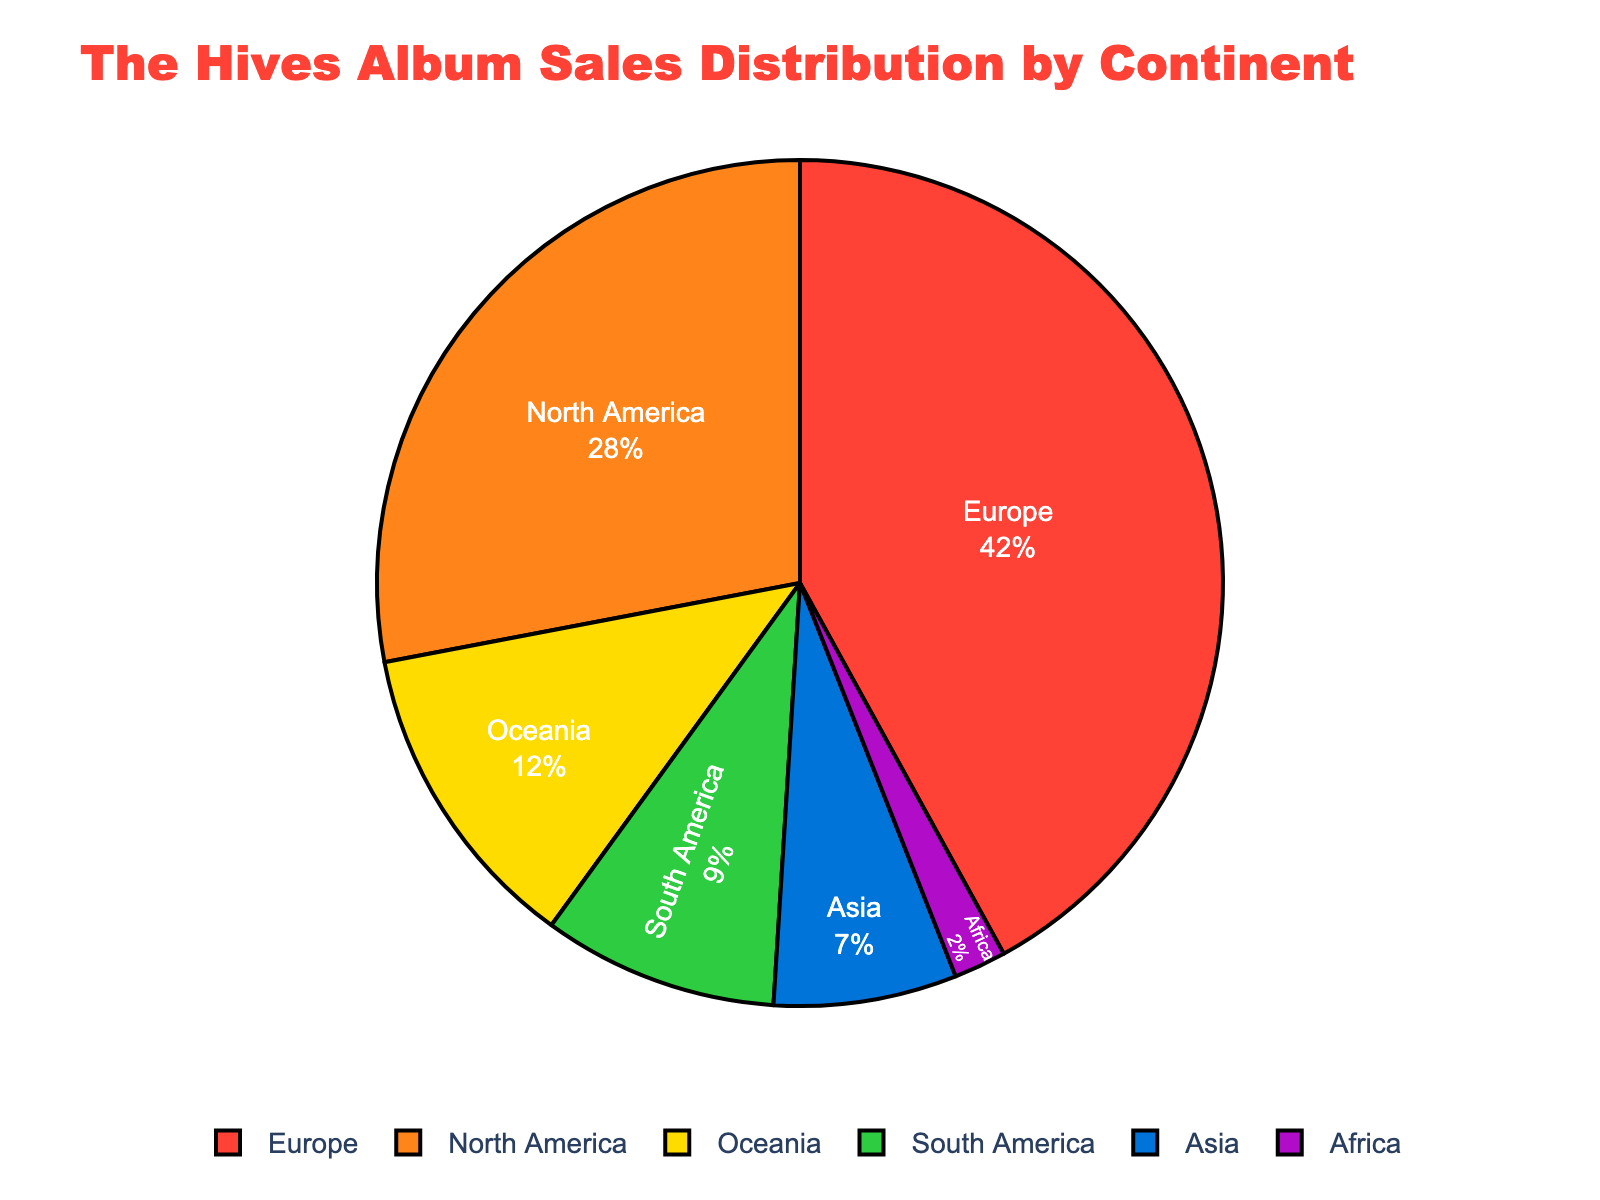Which continent accounts for the largest percentage of The Hives' album sales? The largest percentage in the pie chart is represented by Europe, which takes up the biggest segment of the pie chart.
Answer: Europe What is the total percentage of album sales for continents in the Americas (North and South America combined)? North America accounts for 28% and South America accounts for 9%. Adding these two values gives 28% + 9% = 37%.
Answer: 37% Which continent has the smallest share of album sales, and what is its percentage? The smallest segment in the pie chart corresponds to Africa, which has 2% of the sales.
Answer: Africa, 2% How does the album sales percentage in Oceania compare with that in Asia? Oceania has 12% while Asia has 7%. Comparing the two, Oceania's percentage is greater.
Answer: Oceania's percentage is greater What is the difference in album sales percentage between Europe and Asia? Europe has 42% and Asia has 7%. The difference between these values is 42% - 7% = 35%.
Answer: 35% What percentage of album sales are attributed to Oceania and Africa combined? Oceania accounts for 12% and Africa accounts for 2%. Adding these values together gives 12% + 2% = 14%.
Answer: 14% Which region has closer album sales percentage to Asia, South America or Africa? Asia has 7%, South America has 9%, and Africa has 2%. The difference with South America is 9% - 7% = 2%, and with Africa it is 7% - 2% = 5%. Therefore, South America is closer.
Answer: South America What proportion of album sales does Europe account for relative to North America? Europe has 42% and North America has 28%. The proportion can be calculated as 42% / 28% = 1.5, meaning Europe has 1.5 times the album sales percentage of North America.
Answer: 1.5 times What is the combined percentage of album sales for Asia, Oceania, and Africa? Asia has 7%, Oceania has 12%, and Africa has 2%. Adding these values together gives 7% + 12% + 2% = 21%.
Answer: 21% 